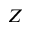<formula> <loc_0><loc_0><loc_500><loc_500>Z</formula> 